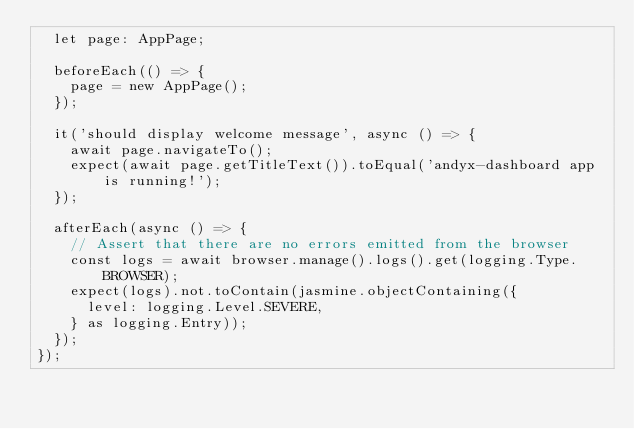<code> <loc_0><loc_0><loc_500><loc_500><_TypeScript_>  let page: AppPage;

  beforeEach(() => {
    page = new AppPage();
  });

  it('should display welcome message', async () => {
    await page.navigateTo();
    expect(await page.getTitleText()).toEqual('andyx-dashboard app is running!');
  });

  afterEach(async () => {
    // Assert that there are no errors emitted from the browser
    const logs = await browser.manage().logs().get(logging.Type.BROWSER);
    expect(logs).not.toContain(jasmine.objectContaining({
      level: logging.Level.SEVERE,
    } as logging.Entry));
  });
});
</code> 